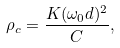Convert formula to latex. <formula><loc_0><loc_0><loc_500><loc_500>\rho _ { c } = \frac { K ( \omega _ { 0 } d ) ^ { 2 } } { C } ,</formula> 